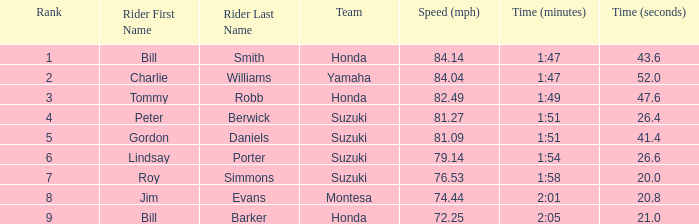What time did peter berwick of team suzuki register? 1:51.26.4. 